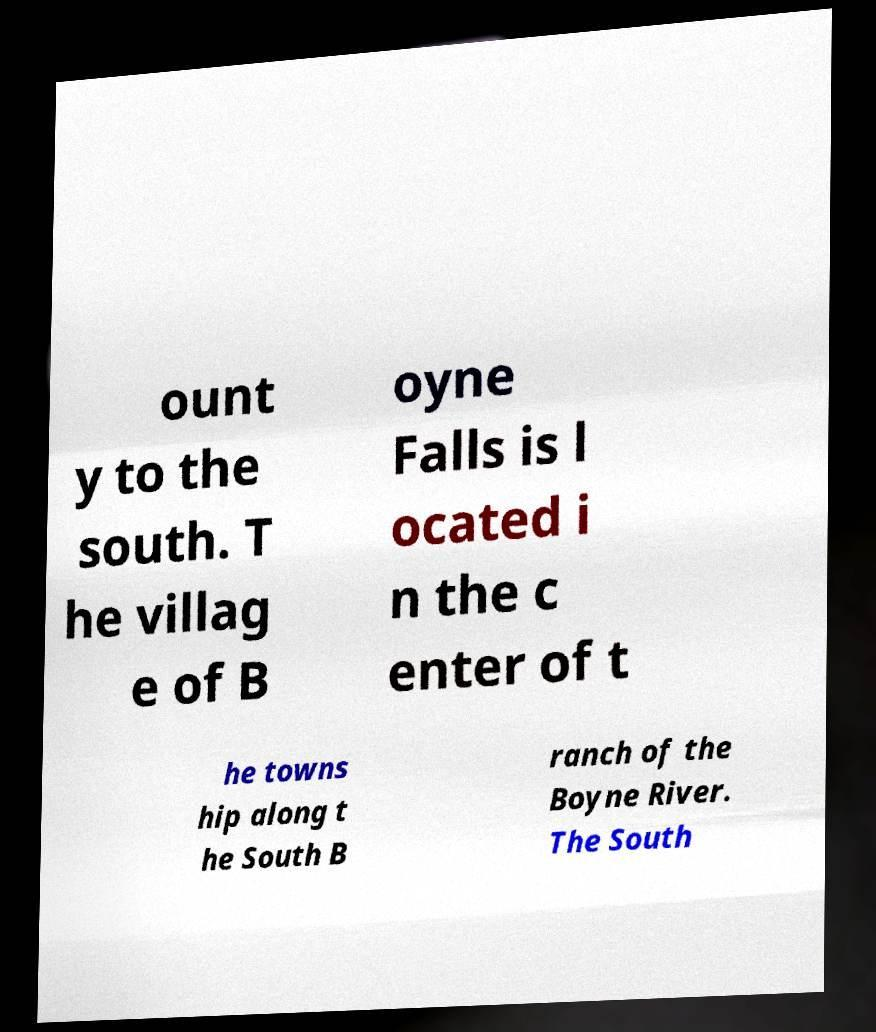There's text embedded in this image that I need extracted. Can you transcribe it verbatim? ount y to the south. T he villag e of B oyne Falls is l ocated i n the c enter of t he towns hip along t he South B ranch of the Boyne River. The South 